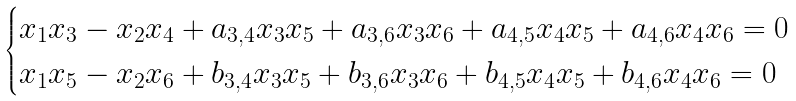<formula> <loc_0><loc_0><loc_500><loc_500>\begin{cases} x _ { 1 } x _ { 3 } - x _ { 2 } x _ { 4 } + a _ { 3 , 4 } x _ { 3 } x _ { 5 } + a _ { 3 , 6 } x _ { 3 } x _ { 6 } + a _ { 4 , 5 } x _ { 4 } x _ { 5 } + a _ { 4 , 6 } x _ { 4 } x _ { 6 } = 0 \\ x _ { 1 } x _ { 5 } - x _ { 2 } x _ { 6 } + b _ { 3 , 4 } x _ { 3 } x _ { 5 } + b _ { 3 , 6 } x _ { 3 } x _ { 6 } + b _ { 4 , 5 } x _ { 4 } x _ { 5 } + b _ { 4 , 6 } x _ { 4 } x _ { 6 } = 0 \end{cases}</formula> 